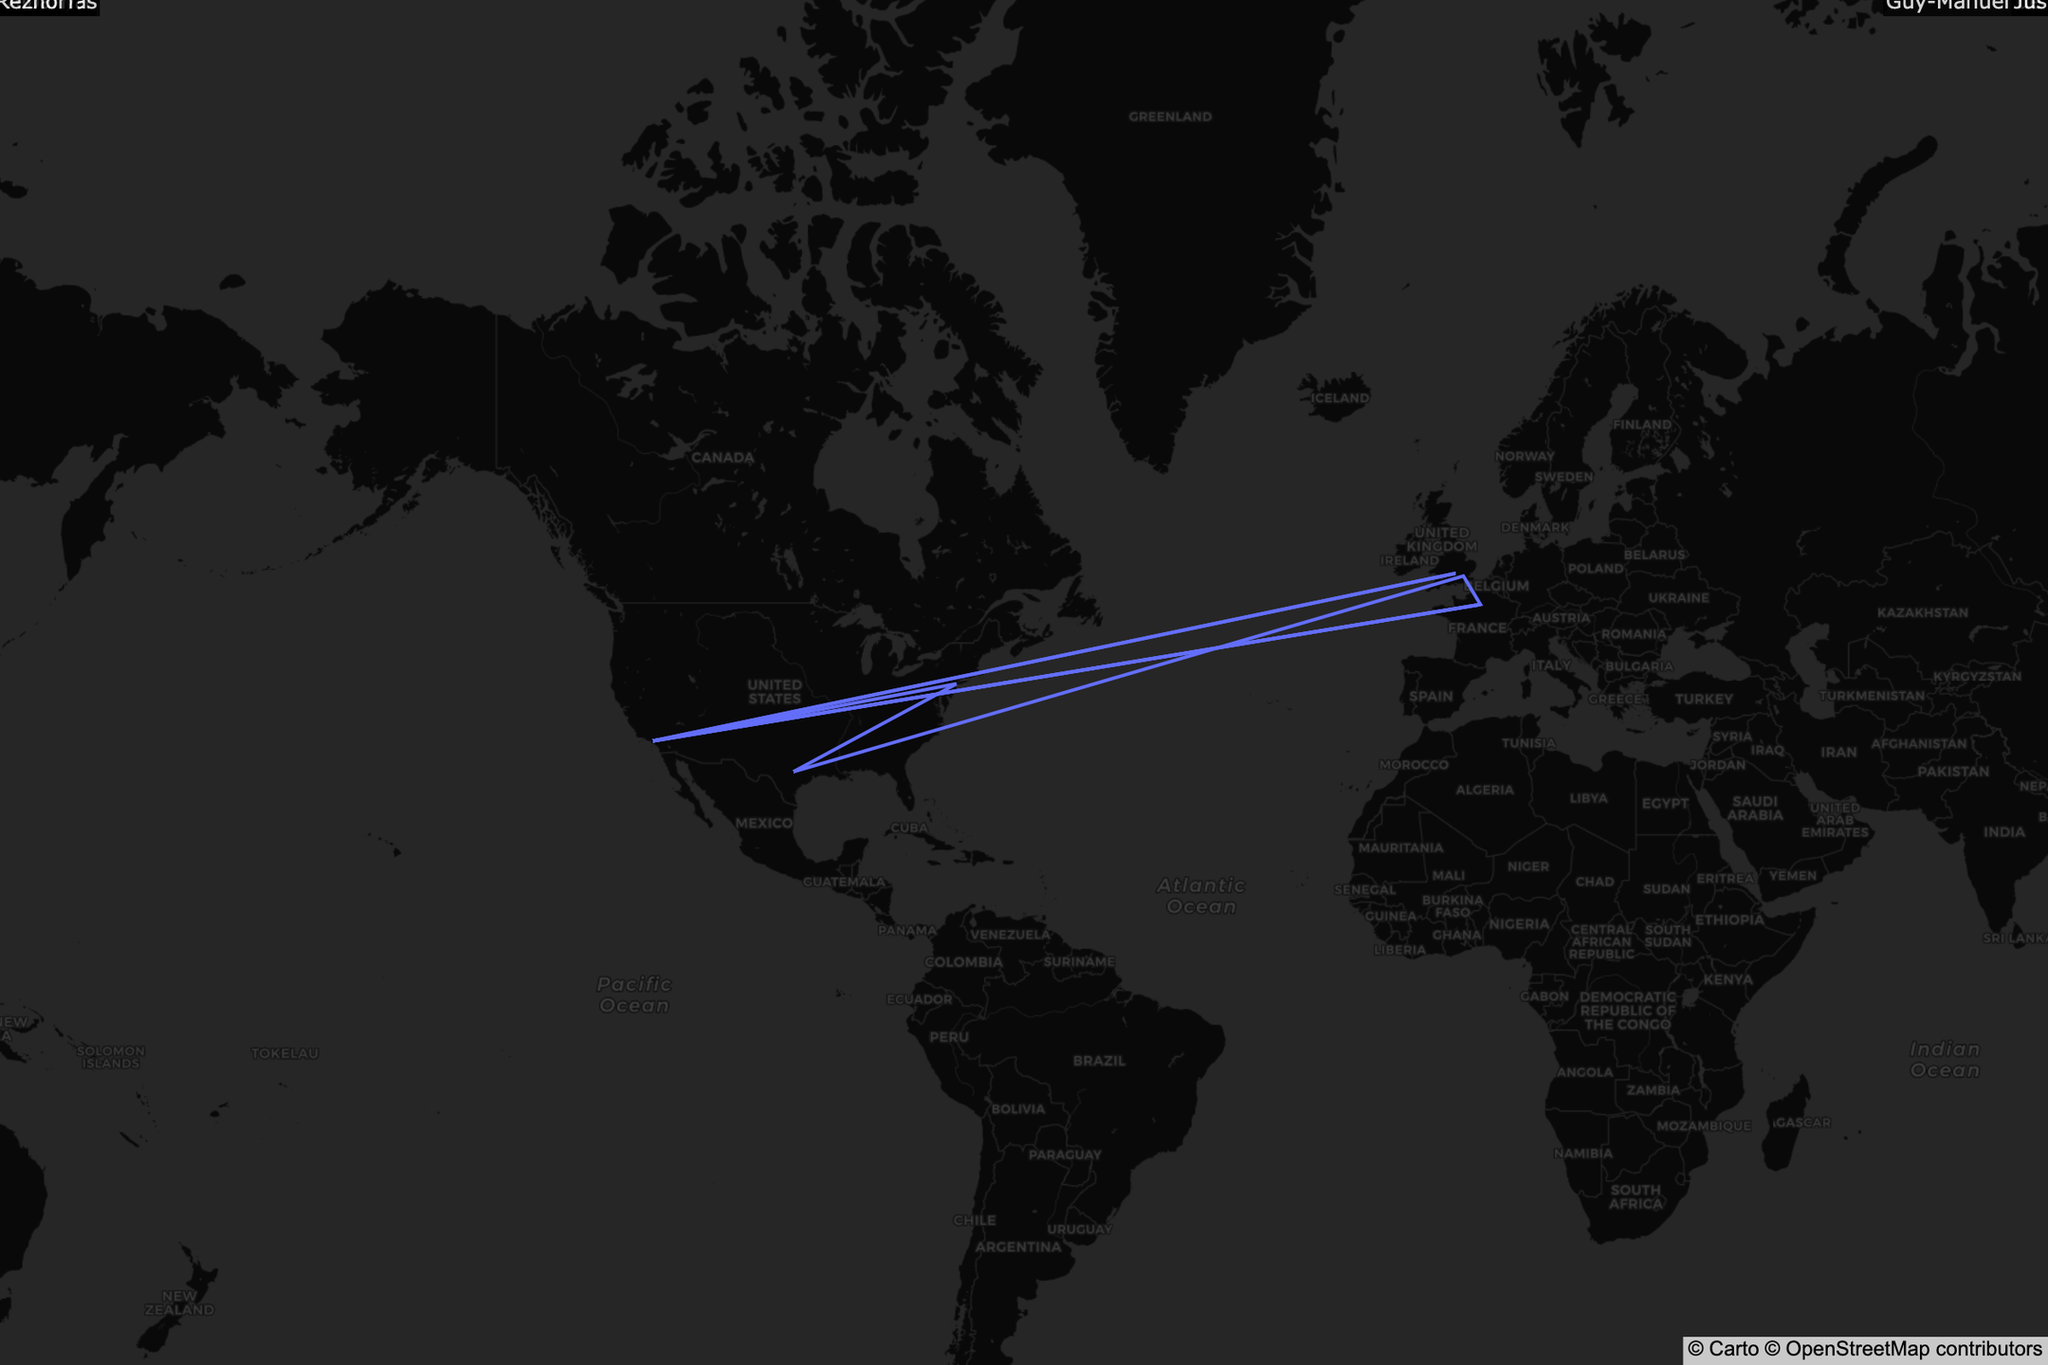Which musician's birthplace and current residence are both in Paris, France? The data shows multiple spots, and identifying the musician related to both birth and current residence in Paris is key. By inspecting the markers and reading the annotations, we find that Justice's birthplace and current residence are in Paris, France.
Answer: Justice How many musicians currently reside in Los Angeles, USA? By examining the map for clusters of markers and observing the text annotations at each point, we count the number of musicians residing in Los Angeles. Using this method, we find five musicians: Thomas Bangalter, Julian Casablancas, Kevin Parker, Trent Reznor, and Thomas Bangalter.
Answer: Five What is the northernmost birthplace location on the map? The northernmost location corresponds to the highest latitude value. Looking at the markers and their annotations, it is found that the northernmost birthplace is Vancouver, Canada, which belongs to Grimes.
Answer: Vancouver, Canada Which genre has more musicians on this map? We count markers, distinguishing them by color representing genres, to see that there are more "Electronic" genre musicians than "Indie Rock."
Answer: Electronic Which musician moved the farthest from their birthplace to their current residence? Calculating the distance between birthplaces and current residences for each musician, the furthest relocation from Perth, Australia to Los Angeles, USA was made by Kevin Parker, by utilizing the large geographical span on the map.
Answer: Kevin Parker Who is the musician born in New Castle, USA and where do they currently reside? Finding New Castle on the map and reading the annotation shows it is Trent Reznor's birthplace. His current residence is in Los Angeles, USA.
Answer: Trent Reznor, Los Angeles, USA Compare the distance of Julian Casablancas’ and Thomas Bangalter’s relocations. Who moved farther? Both current residences are in Los Angeles, USA. Julian's birthplace is New York City, whereas Thomas' birthplace is Paris. Paris to Los Angeles measurement results in a greater distance than New York to Los Angeles.
Answer: Thomas Bangalter Which musician's current residence is in Austin, USA? The marker and annotation reveal that the musician currently residing in Austin is Grimes. Checking against the map for precision.
Answer: Grimes Count the musicians born in Paris, France. Review all markers and annotations to identify how many musicians were born in Paris, France by counting these specific pieces of information. We see Thomas Bangalter and Justice, hence there are two.
Answer: Two 